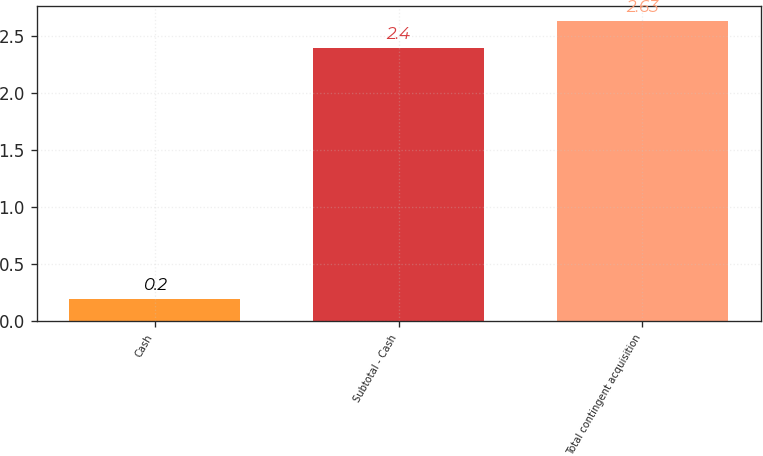<chart> <loc_0><loc_0><loc_500><loc_500><bar_chart><fcel>Cash<fcel>Subtotal - Cash<fcel>Total contingent acquisition<nl><fcel>0.2<fcel>2.4<fcel>2.63<nl></chart> 